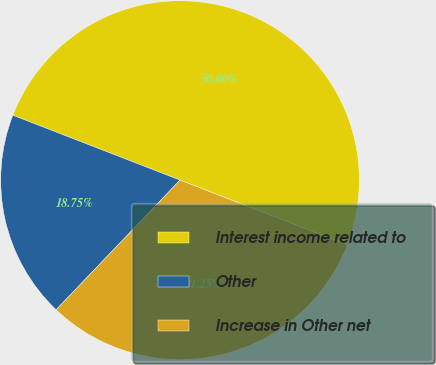Convert chart to OTSL. <chart><loc_0><loc_0><loc_500><loc_500><pie_chart><fcel>Interest income related to<fcel>Other<fcel>Increase in Other net<nl><fcel>50.0%<fcel>18.75%<fcel>31.25%<nl></chart> 